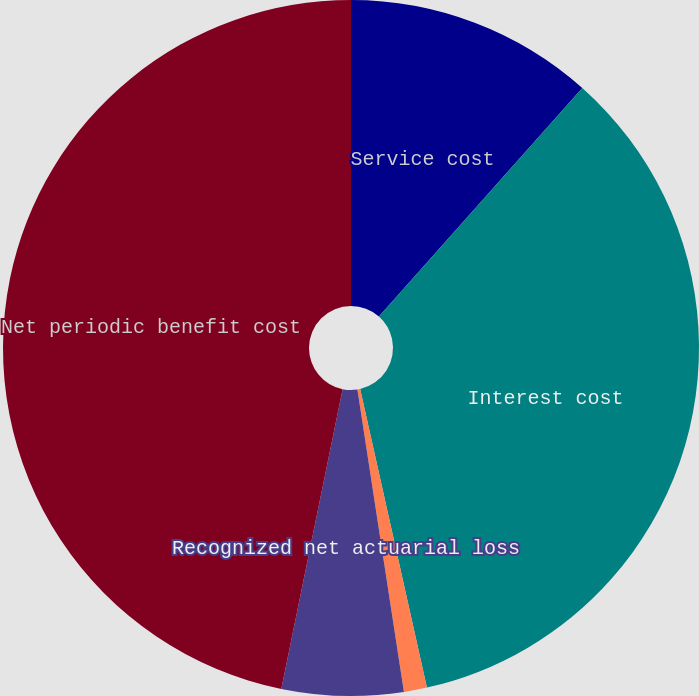<chart> <loc_0><loc_0><loc_500><loc_500><pie_chart><fcel>Service cost<fcel>Interest cost<fcel>Amortization of prior service<fcel>Recognized net actuarial loss<fcel>Net periodic benefit cost<nl><fcel>11.57%<fcel>34.93%<fcel>1.07%<fcel>5.64%<fcel>46.79%<nl></chart> 